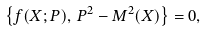<formula> <loc_0><loc_0><loc_500><loc_500>\left \{ f ( X ; P ) , \, P ^ { 2 } - M ^ { 2 } ( X ) \right \} = 0 ,</formula> 